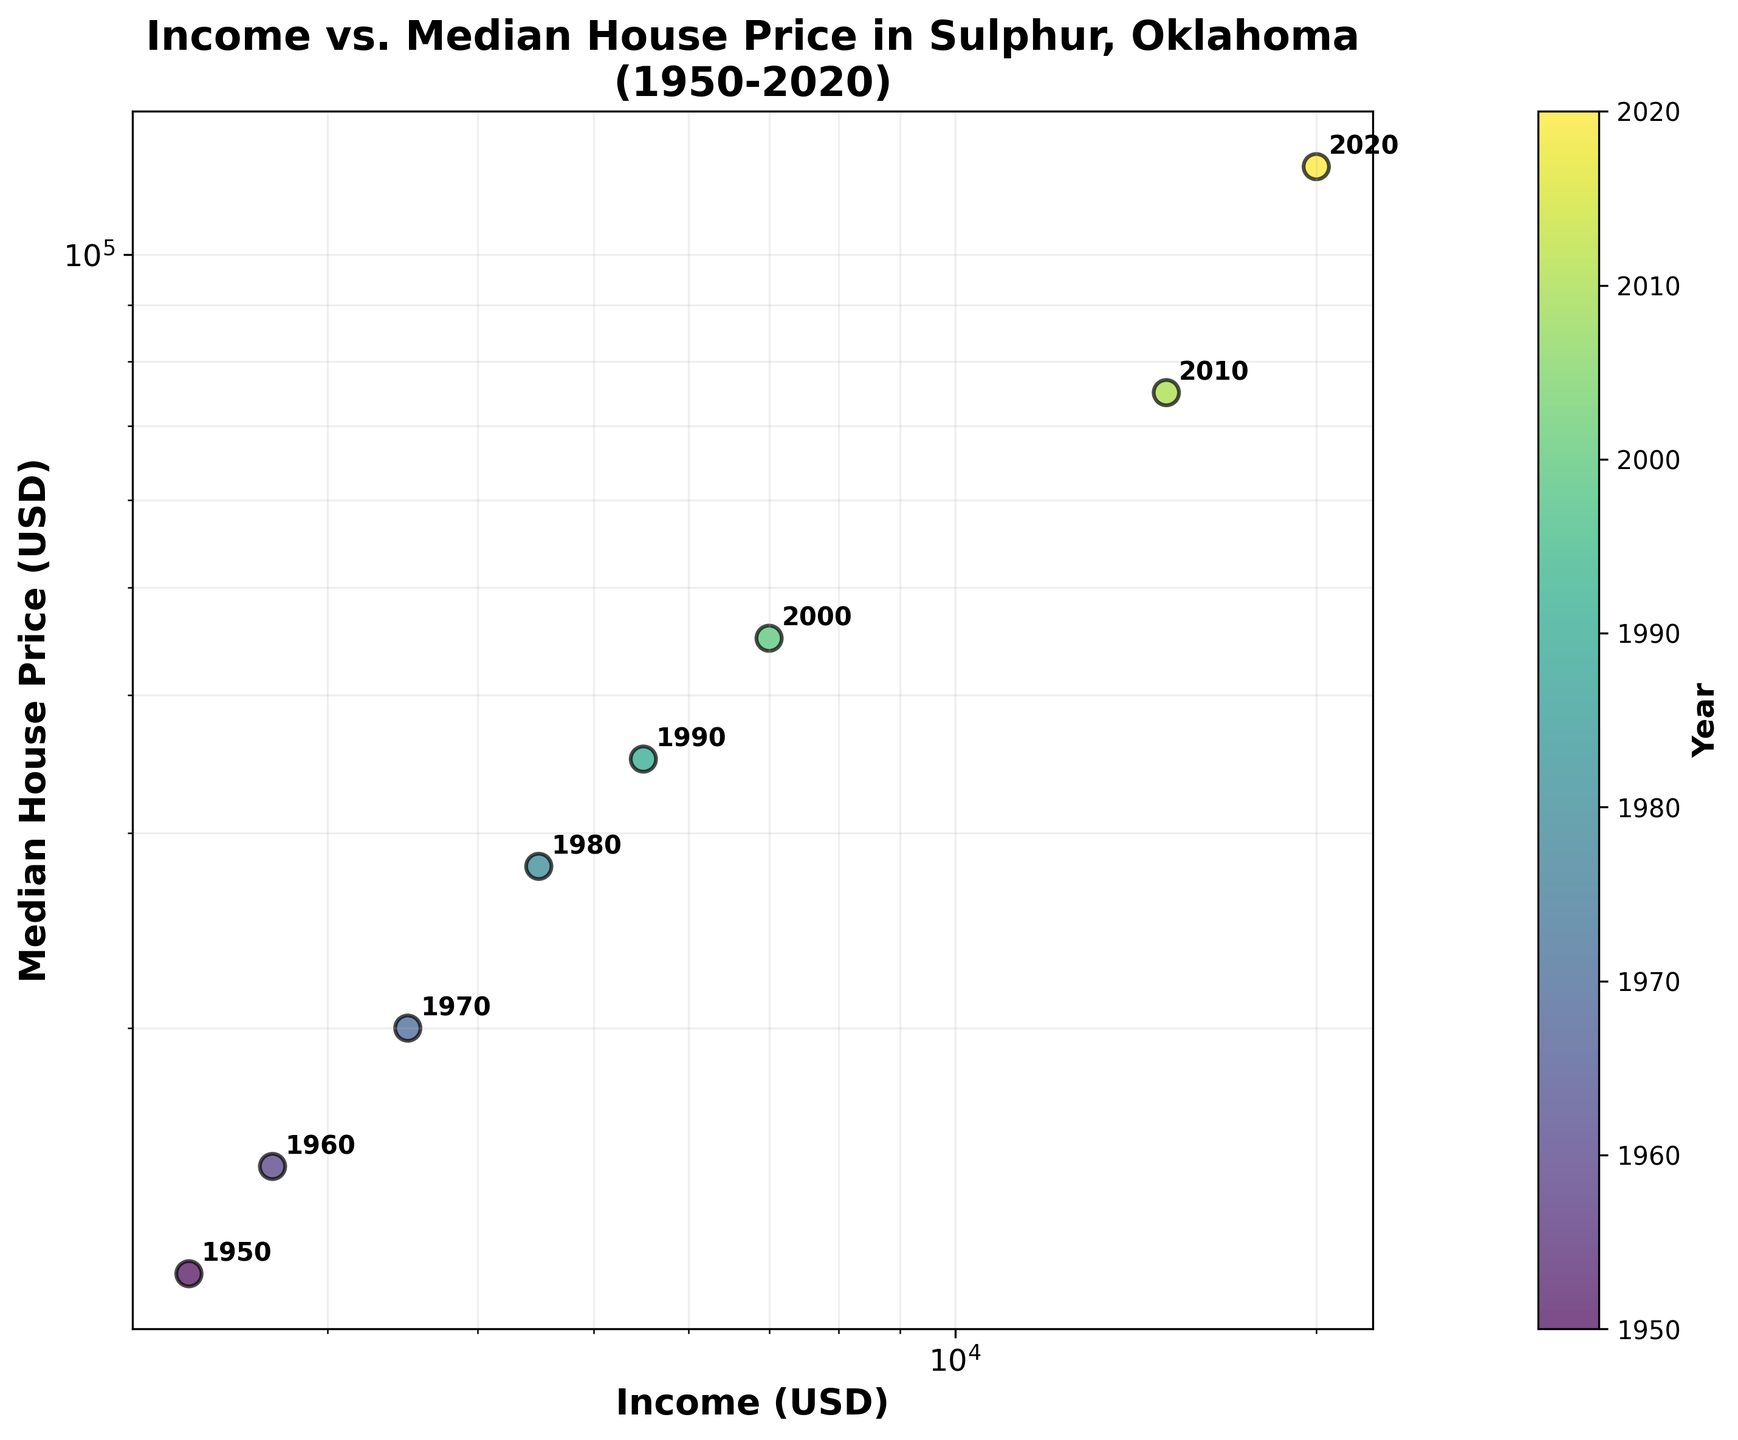What's the title of the scatter plot? The title is usually located at the top center of the plot and summarizes what the plot is about. The title here reads, "Income vs. Median House Price in Sulphur, Oklahoma (1950-2020)"
Answer: Income vs. Median House Price in Sulphur, Oklahoma (1950-2020) What axis scales are used in the scatter plot? In the scatter plot, both the x and y axes are marked with lines and scales. The labels "log" on both axes indicate that the plot uses a logarithmic scale for both the Income and Median House Price.
Answer: Log-Log Scale How many data points are represented in the scatter plot? Each point on the scatter plot corresponds to a year in the dataset. By counting the number of points or annotated labels, you can determine there are 8 data points.
Answer: 8 Which year had the highest median house price, and what was that price? By looking at the y-axis (Median House Price) and the color scale, the highest value corresponds to 2020, with a median house price of $120,000.
Answer: 2020, $120,000 What is the rate of change in income from 1950 to 2020? Calculate the difference in income between 2020 and 1950, and divide it by the number of years between these two dates. The income in 1950 was $2300 and in 2020 it was $20000. So, (20000-2300) / (2020-1950) = 17700 / 70 ≈ $253 per year
Answer: $253 per year During which decade did the median house price see the most significant jump? By examining the y-axis values and looking for the largest vertical gap between consecutive points, we notice the biggest jump occurred between 2010 ($75,000) and 2020 ($120,000), an increase of $45,000.
Answer: 2010-2020 Is there a general trend between income and median house price from 1950 to 2020? To determine the trend, observe the general direction in which the points move. As income increases, the median house price also tends to increase. This indicates a positive correlation.
Answer: Positive Correlation What was the income in 1970 and how does it compare to the income in 1960? From the x-axis, the income for 1970 is $3500 and for 1960 it is $2700. Compare these two values: $3500 is greater than $2700.
Answer: $3500, higher than $2700 What is the relationship between median house price in 1980 and 1990? By checking the y-axis, the median house price in 1980 is $28,000 and in 1990 it is $35,000. Comparing these values, we see the median house price in 1990 is higher.
Answer: 1990 is higher than 1980 